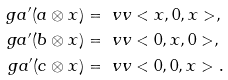Convert formula to latex. <formula><loc_0><loc_0><loc_500><loc_500>\ g a ^ { \prime } ( a \otimes x ) & = \ v v < x , 0 , x > , \\ \ g a ^ { \prime } ( b \otimes x ) & = \ v v < 0 , x , 0 > , \\ \ g a ^ { \prime } ( c \otimes x ) & = \ v v < 0 , 0 , x > .</formula> 